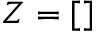<formula> <loc_0><loc_0><loc_500><loc_500>Z = [ ]</formula> 